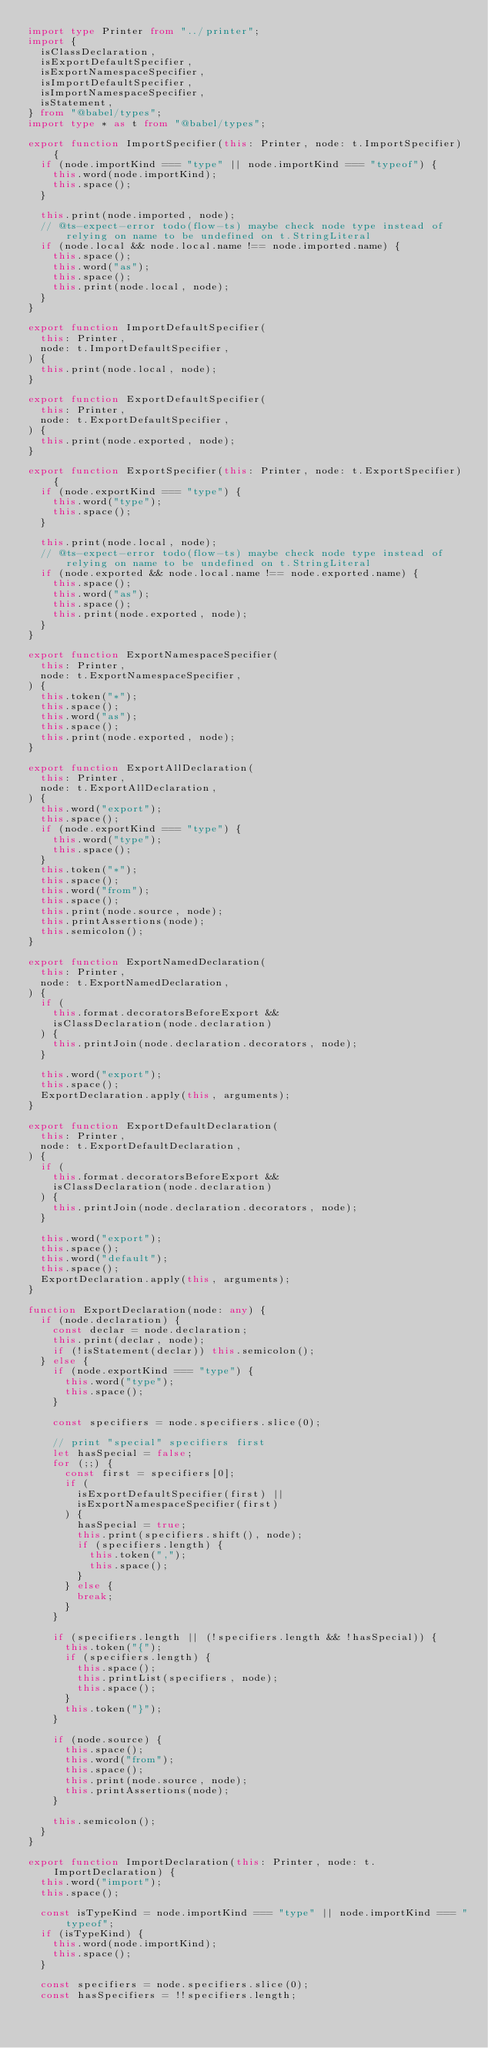Convert code to text. <code><loc_0><loc_0><loc_500><loc_500><_TypeScript_>import type Printer from "../printer";
import {
  isClassDeclaration,
  isExportDefaultSpecifier,
  isExportNamespaceSpecifier,
  isImportDefaultSpecifier,
  isImportNamespaceSpecifier,
  isStatement,
} from "@babel/types";
import type * as t from "@babel/types";

export function ImportSpecifier(this: Printer, node: t.ImportSpecifier) {
  if (node.importKind === "type" || node.importKind === "typeof") {
    this.word(node.importKind);
    this.space();
  }

  this.print(node.imported, node);
  // @ts-expect-error todo(flow-ts) maybe check node type instead of relying on name to be undefined on t.StringLiteral
  if (node.local && node.local.name !== node.imported.name) {
    this.space();
    this.word("as");
    this.space();
    this.print(node.local, node);
  }
}

export function ImportDefaultSpecifier(
  this: Printer,
  node: t.ImportDefaultSpecifier,
) {
  this.print(node.local, node);
}

export function ExportDefaultSpecifier(
  this: Printer,
  node: t.ExportDefaultSpecifier,
) {
  this.print(node.exported, node);
}

export function ExportSpecifier(this: Printer, node: t.ExportSpecifier) {
  if (node.exportKind === "type") {
    this.word("type");
    this.space();
  }

  this.print(node.local, node);
  // @ts-expect-error todo(flow-ts) maybe check node type instead of relying on name to be undefined on t.StringLiteral
  if (node.exported && node.local.name !== node.exported.name) {
    this.space();
    this.word("as");
    this.space();
    this.print(node.exported, node);
  }
}

export function ExportNamespaceSpecifier(
  this: Printer,
  node: t.ExportNamespaceSpecifier,
) {
  this.token("*");
  this.space();
  this.word("as");
  this.space();
  this.print(node.exported, node);
}

export function ExportAllDeclaration(
  this: Printer,
  node: t.ExportAllDeclaration,
) {
  this.word("export");
  this.space();
  if (node.exportKind === "type") {
    this.word("type");
    this.space();
  }
  this.token("*");
  this.space();
  this.word("from");
  this.space();
  this.print(node.source, node);
  this.printAssertions(node);
  this.semicolon();
}

export function ExportNamedDeclaration(
  this: Printer,
  node: t.ExportNamedDeclaration,
) {
  if (
    this.format.decoratorsBeforeExport &&
    isClassDeclaration(node.declaration)
  ) {
    this.printJoin(node.declaration.decorators, node);
  }

  this.word("export");
  this.space();
  ExportDeclaration.apply(this, arguments);
}

export function ExportDefaultDeclaration(
  this: Printer,
  node: t.ExportDefaultDeclaration,
) {
  if (
    this.format.decoratorsBeforeExport &&
    isClassDeclaration(node.declaration)
  ) {
    this.printJoin(node.declaration.decorators, node);
  }

  this.word("export");
  this.space();
  this.word("default");
  this.space();
  ExportDeclaration.apply(this, arguments);
}

function ExportDeclaration(node: any) {
  if (node.declaration) {
    const declar = node.declaration;
    this.print(declar, node);
    if (!isStatement(declar)) this.semicolon();
  } else {
    if (node.exportKind === "type") {
      this.word("type");
      this.space();
    }

    const specifiers = node.specifiers.slice(0);

    // print "special" specifiers first
    let hasSpecial = false;
    for (;;) {
      const first = specifiers[0];
      if (
        isExportDefaultSpecifier(first) ||
        isExportNamespaceSpecifier(first)
      ) {
        hasSpecial = true;
        this.print(specifiers.shift(), node);
        if (specifiers.length) {
          this.token(",");
          this.space();
        }
      } else {
        break;
      }
    }

    if (specifiers.length || (!specifiers.length && !hasSpecial)) {
      this.token("{");
      if (specifiers.length) {
        this.space();
        this.printList(specifiers, node);
        this.space();
      }
      this.token("}");
    }

    if (node.source) {
      this.space();
      this.word("from");
      this.space();
      this.print(node.source, node);
      this.printAssertions(node);
    }

    this.semicolon();
  }
}

export function ImportDeclaration(this: Printer, node: t.ImportDeclaration) {
  this.word("import");
  this.space();

  const isTypeKind = node.importKind === "type" || node.importKind === "typeof";
  if (isTypeKind) {
    this.word(node.importKind);
    this.space();
  }

  const specifiers = node.specifiers.slice(0);
  const hasSpecifiers = !!specifiers.length;</code> 